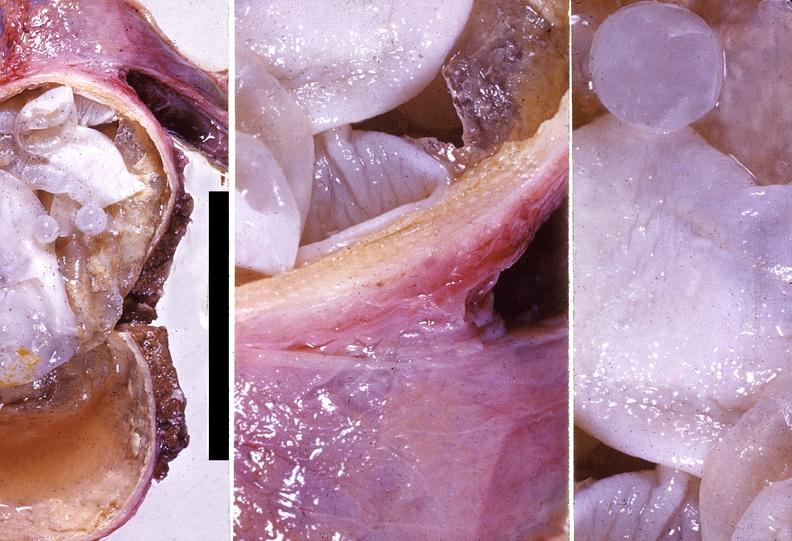s hepatobiliary present?
Answer the question using a single word or phrase. Yes 